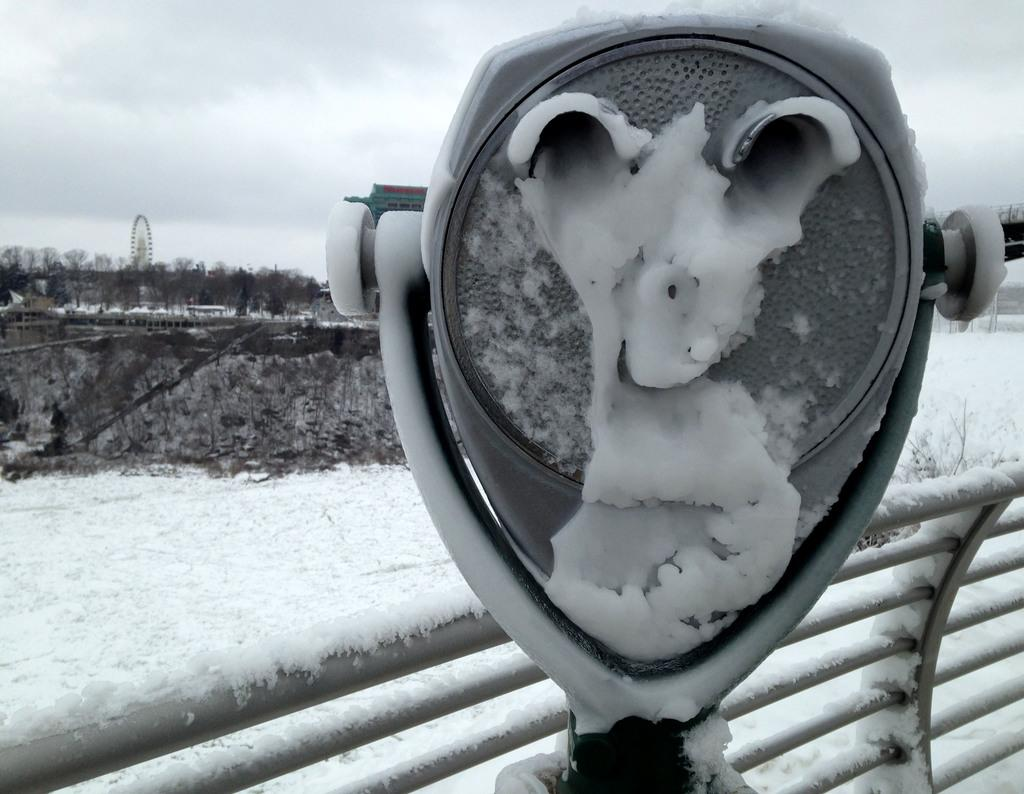What object can be seen in the image for parking payment? There is a parking meter in the image. What type of security feature is present in the image? There are iron grilles in the image. What weather condition is depicted in the image? There is snow visible in the image. What type of vegetation can be seen in the background of the image? There are trees in the background of the image. What type of amusement ride is visible in the background of the image? There is a Ferris wheel in the background of the image. What part of the natural environment is visible in the background of the image? The sky is visible in the background of the image. What type of teeth can be seen in the image? There are no teeth visible in the image. What type of vacation destination is depicted in the image? The image does not depict a vacation destination; it shows a parking meter, iron grilles, snow, trees, a Ferris wheel, and the sky. 